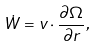Convert formula to latex. <formula><loc_0><loc_0><loc_500><loc_500>\dot { W } = { v } \cdot \frac { \partial \Omega } { { \partial { r } } } ,</formula> 